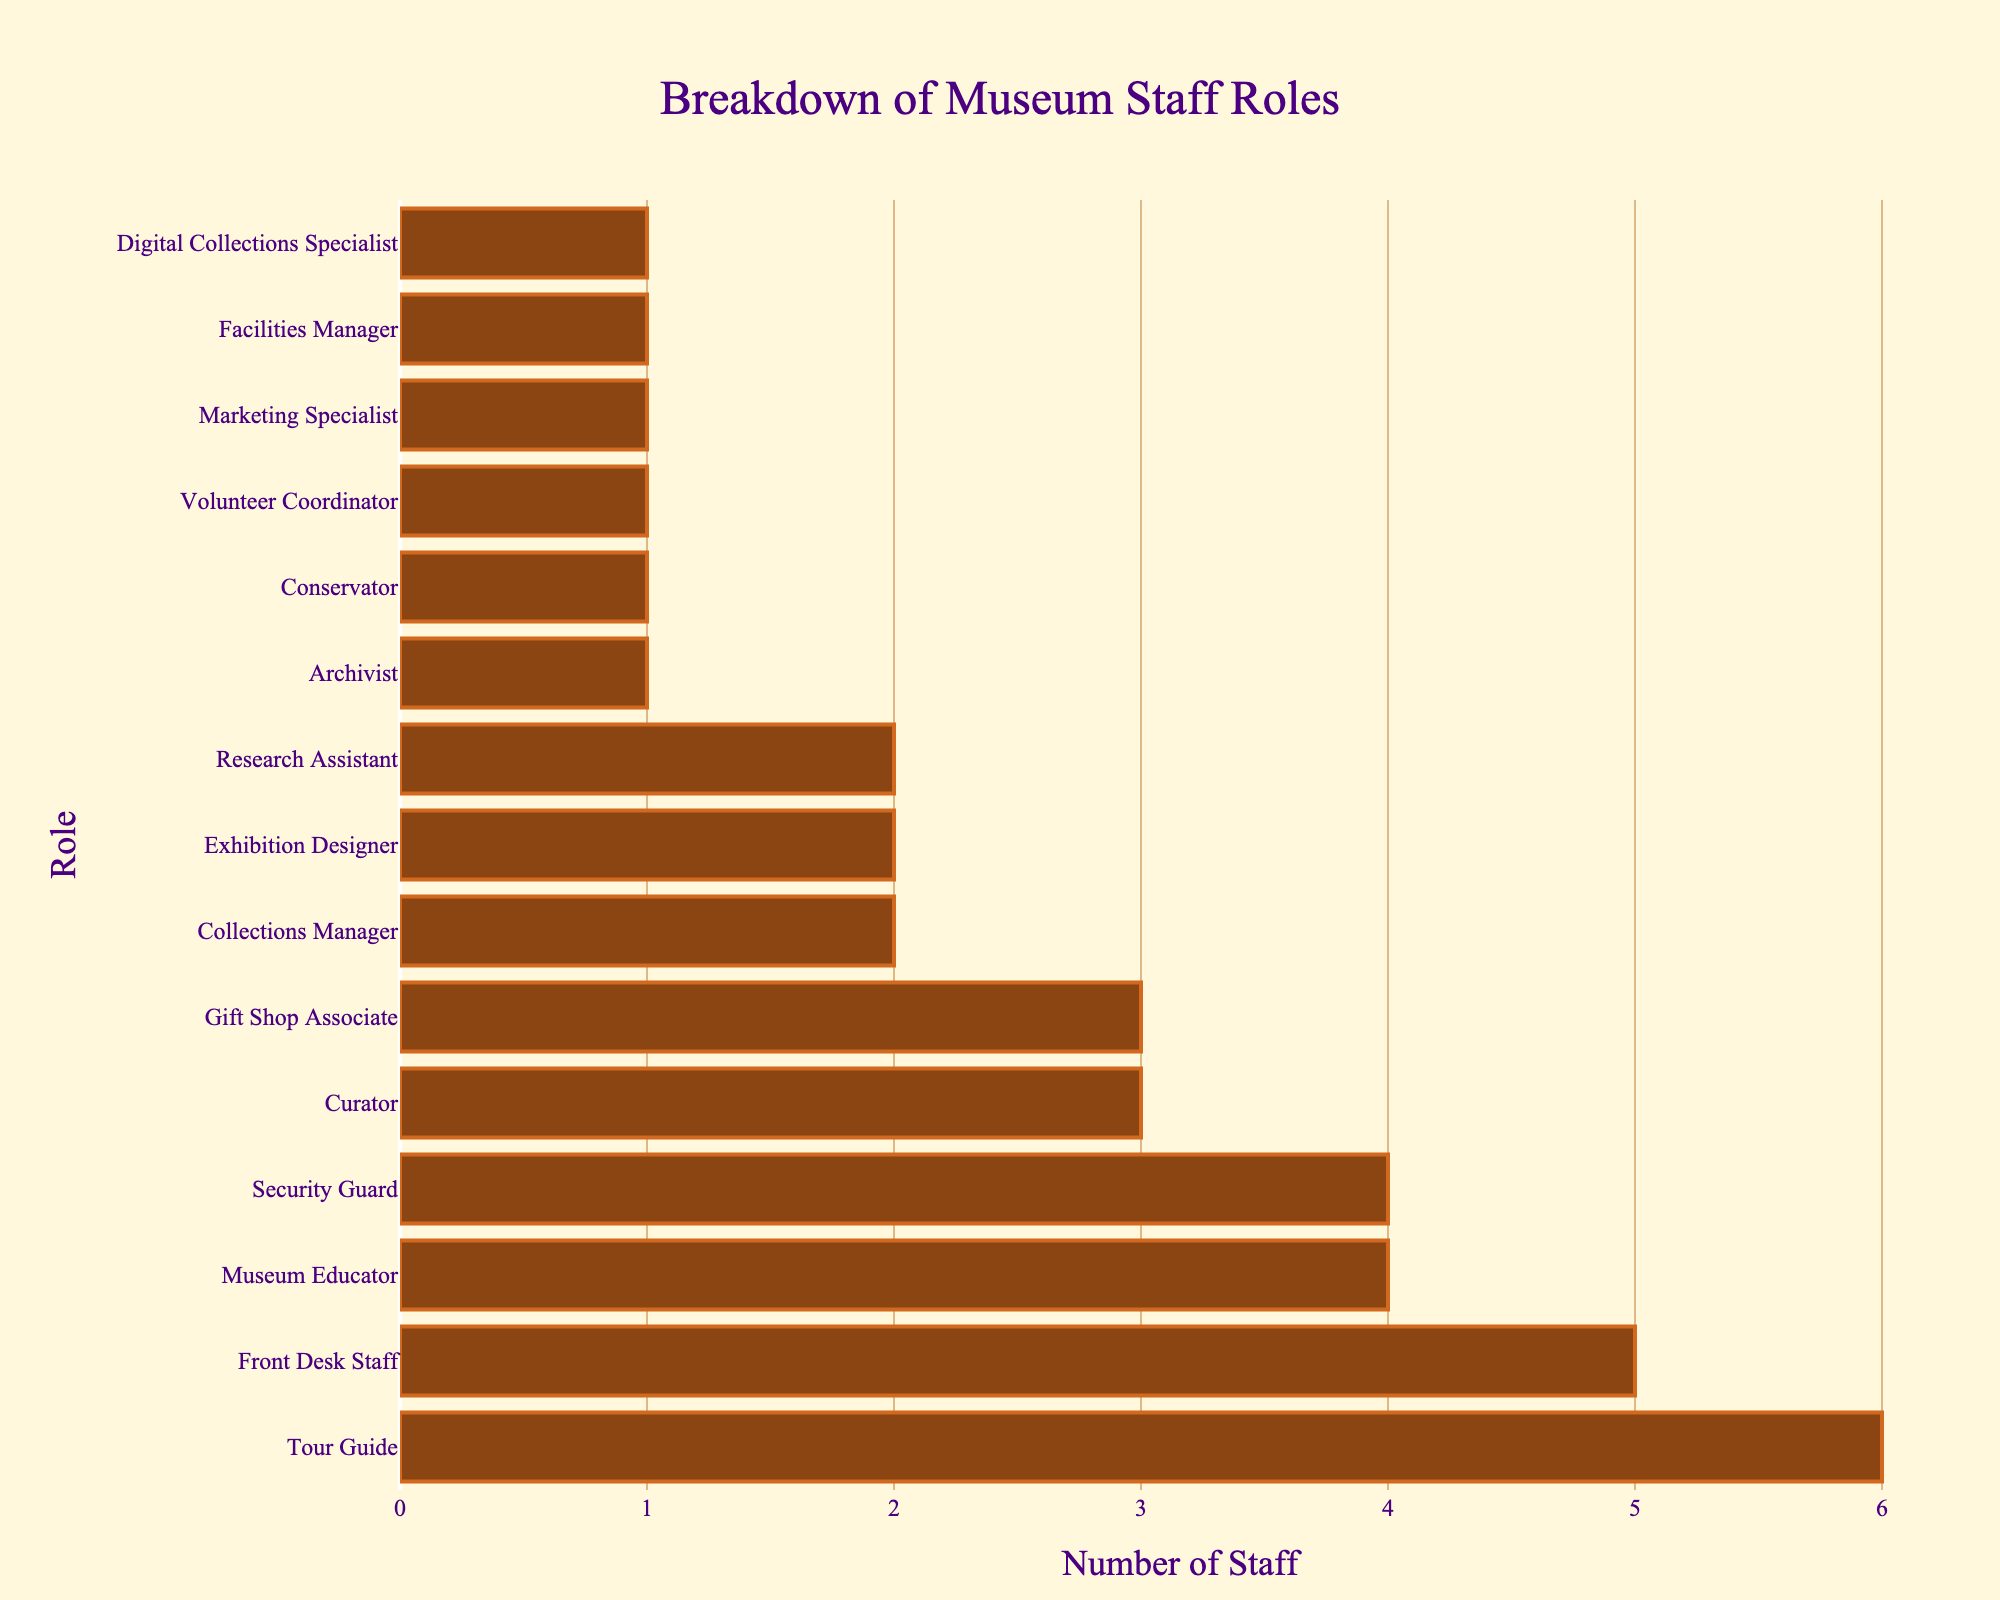What's the most common staff role at the museum? The bar for Tour Guide is the longest, indicating the highest number of staff.
Answer: Tour Guide How many more Museum Educators are there compared to Research Assistants? Museum Educators: 4, Research Assistants: 2. The difference is 4 - 2 = 2.
Answer: 2 Which staff roles have only 1 person? The bars with height of 1 correspond to Archivist, Conservator, Volunteer Coordinator, Marketing Specialist, Facilities Manager, and Digital Collections Specialist.
Answer: Archivist, Conservator, Volunteer Coordinator, Marketing Specialist, Facilities Manager, Digital Collections Specialist What is the total number of staff working in roles listed in the figure? Adding all staff numbers: 3 (Curator) + 4 (Museum Educator) + 2 (Collections Manager) + 1 (Archivist) + 5 (Front Desk Staff) + 1 (Conservator) + 1 (Volunteer Coordinator) + 2 (Exhibition Designer) + 1 (Marketing Specialist) + 1 (Facilities Manager) + 2 (Research Assistant) + 3 (Gift Shop Associate) + 4 (Security Guard) + 6 (Tour Guide) + 1 (Digital Collections Specialist) = 37
Answer: 37 What percentage of the staff are Tour Guides? Number of Tour Guides: 6, Total staff: 37. Percentage = (6/37) * 100 ≈ 16.2%
Answer: 16.2% How many roles have more than 3 staff members? Tour Guide (6), Front Desk Staff (5), Museum Educator (4), and Security Guard (4) each have more than 3 staff. There are 4 such roles.
Answer: 4 Which roles have the same number of staff? Museum Educator and Security Guard both have 4 staff each. Collections Manager, Exhibition Designer, and Research Assistant each have 2 staff. Curator and Gift Shop Associate each have 3 staff.
Answer: Museum Educator & Security Guard, Collections Manager & Exhibition Designer & Research Assistant, Curator & Gift Shop Associate Among the roles with exactly one staff member, which appears first alphabetically? The roles with one staff member are Archivist, Conservator, Volunteer Coordinator, Marketing Specialist, Facilities Manager, and Digital Collections Specialist. Alphabetically, Archivist comes first.
Answer: Archivist Which role has the least number of staff after Tour Guide? The role with the highest number of staff is Tour Guide (6). The next highest is Front Desk Staff (5).
Answer: Front Desk Staff 